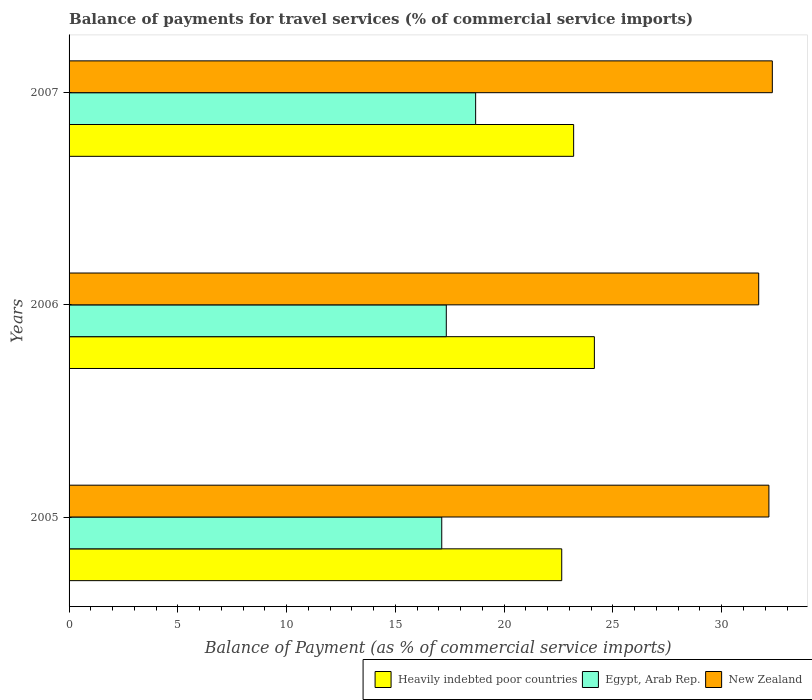How many different coloured bars are there?
Keep it short and to the point. 3. How many groups of bars are there?
Offer a very short reply. 3. Are the number of bars on each tick of the Y-axis equal?
Keep it short and to the point. Yes. How many bars are there on the 2nd tick from the top?
Make the answer very short. 3. What is the label of the 2nd group of bars from the top?
Your answer should be very brief. 2006. In how many cases, is the number of bars for a given year not equal to the number of legend labels?
Offer a very short reply. 0. What is the balance of payments for travel services in Heavily indebted poor countries in 2006?
Provide a succinct answer. 24.15. Across all years, what is the maximum balance of payments for travel services in Egypt, Arab Rep.?
Keep it short and to the point. 18.69. Across all years, what is the minimum balance of payments for travel services in New Zealand?
Ensure brevity in your answer.  31.7. In which year was the balance of payments for travel services in Heavily indebted poor countries maximum?
Keep it short and to the point. 2006. What is the total balance of payments for travel services in Heavily indebted poor countries in the graph?
Offer a very short reply. 69.99. What is the difference between the balance of payments for travel services in New Zealand in 2006 and that in 2007?
Provide a succinct answer. -0.63. What is the difference between the balance of payments for travel services in Egypt, Arab Rep. in 2006 and the balance of payments for travel services in Heavily indebted poor countries in 2007?
Ensure brevity in your answer.  -5.85. What is the average balance of payments for travel services in Heavily indebted poor countries per year?
Your answer should be compact. 23.33. In the year 2005, what is the difference between the balance of payments for travel services in Egypt, Arab Rep. and balance of payments for travel services in Heavily indebted poor countries?
Provide a succinct answer. -5.52. In how many years, is the balance of payments for travel services in Egypt, Arab Rep. greater than 22 %?
Provide a succinct answer. 0. What is the ratio of the balance of payments for travel services in Egypt, Arab Rep. in 2005 to that in 2007?
Offer a terse response. 0.92. What is the difference between the highest and the second highest balance of payments for travel services in Egypt, Arab Rep.?
Keep it short and to the point. 1.35. What is the difference between the highest and the lowest balance of payments for travel services in Egypt, Arab Rep.?
Offer a terse response. 1.56. In how many years, is the balance of payments for travel services in Egypt, Arab Rep. greater than the average balance of payments for travel services in Egypt, Arab Rep. taken over all years?
Make the answer very short. 1. Is the sum of the balance of payments for travel services in New Zealand in 2005 and 2006 greater than the maximum balance of payments for travel services in Egypt, Arab Rep. across all years?
Your answer should be compact. Yes. What does the 1st bar from the top in 2007 represents?
Make the answer very short. New Zealand. What does the 2nd bar from the bottom in 2006 represents?
Your answer should be compact. Egypt, Arab Rep. Is it the case that in every year, the sum of the balance of payments for travel services in Egypt, Arab Rep. and balance of payments for travel services in New Zealand is greater than the balance of payments for travel services in Heavily indebted poor countries?
Offer a very short reply. Yes. How many bars are there?
Ensure brevity in your answer.  9. Are the values on the major ticks of X-axis written in scientific E-notation?
Your response must be concise. No. Where does the legend appear in the graph?
Provide a succinct answer. Bottom right. How are the legend labels stacked?
Give a very brief answer. Horizontal. What is the title of the graph?
Provide a short and direct response. Balance of payments for travel services (% of commercial service imports). What is the label or title of the X-axis?
Offer a terse response. Balance of Payment (as % of commercial service imports). What is the Balance of Payment (as % of commercial service imports) of Heavily indebted poor countries in 2005?
Make the answer very short. 22.65. What is the Balance of Payment (as % of commercial service imports) in Egypt, Arab Rep. in 2005?
Your answer should be very brief. 17.13. What is the Balance of Payment (as % of commercial service imports) in New Zealand in 2005?
Make the answer very short. 32.17. What is the Balance of Payment (as % of commercial service imports) of Heavily indebted poor countries in 2006?
Your response must be concise. 24.15. What is the Balance of Payment (as % of commercial service imports) in Egypt, Arab Rep. in 2006?
Keep it short and to the point. 17.34. What is the Balance of Payment (as % of commercial service imports) in New Zealand in 2006?
Your response must be concise. 31.7. What is the Balance of Payment (as % of commercial service imports) of Heavily indebted poor countries in 2007?
Offer a terse response. 23.19. What is the Balance of Payment (as % of commercial service imports) of Egypt, Arab Rep. in 2007?
Your response must be concise. 18.69. What is the Balance of Payment (as % of commercial service imports) in New Zealand in 2007?
Your answer should be very brief. 32.33. Across all years, what is the maximum Balance of Payment (as % of commercial service imports) of Heavily indebted poor countries?
Provide a short and direct response. 24.15. Across all years, what is the maximum Balance of Payment (as % of commercial service imports) of Egypt, Arab Rep.?
Provide a short and direct response. 18.69. Across all years, what is the maximum Balance of Payment (as % of commercial service imports) of New Zealand?
Give a very brief answer. 32.33. Across all years, what is the minimum Balance of Payment (as % of commercial service imports) of Heavily indebted poor countries?
Provide a short and direct response. 22.65. Across all years, what is the minimum Balance of Payment (as % of commercial service imports) in Egypt, Arab Rep.?
Offer a very short reply. 17.13. Across all years, what is the minimum Balance of Payment (as % of commercial service imports) in New Zealand?
Keep it short and to the point. 31.7. What is the total Balance of Payment (as % of commercial service imports) in Heavily indebted poor countries in the graph?
Offer a terse response. 69.99. What is the total Balance of Payment (as % of commercial service imports) of Egypt, Arab Rep. in the graph?
Offer a terse response. 53.16. What is the total Balance of Payment (as % of commercial service imports) in New Zealand in the graph?
Offer a terse response. 96.19. What is the difference between the Balance of Payment (as % of commercial service imports) in Heavily indebted poor countries in 2005 and that in 2006?
Offer a terse response. -1.5. What is the difference between the Balance of Payment (as % of commercial service imports) of Egypt, Arab Rep. in 2005 and that in 2006?
Offer a terse response. -0.21. What is the difference between the Balance of Payment (as % of commercial service imports) in New Zealand in 2005 and that in 2006?
Offer a very short reply. 0.47. What is the difference between the Balance of Payment (as % of commercial service imports) in Heavily indebted poor countries in 2005 and that in 2007?
Provide a short and direct response. -0.55. What is the difference between the Balance of Payment (as % of commercial service imports) of Egypt, Arab Rep. in 2005 and that in 2007?
Keep it short and to the point. -1.56. What is the difference between the Balance of Payment (as % of commercial service imports) in New Zealand in 2005 and that in 2007?
Provide a succinct answer. -0.16. What is the difference between the Balance of Payment (as % of commercial service imports) of Heavily indebted poor countries in 2006 and that in 2007?
Your response must be concise. 0.95. What is the difference between the Balance of Payment (as % of commercial service imports) in Egypt, Arab Rep. in 2006 and that in 2007?
Provide a succinct answer. -1.35. What is the difference between the Balance of Payment (as % of commercial service imports) in New Zealand in 2006 and that in 2007?
Make the answer very short. -0.63. What is the difference between the Balance of Payment (as % of commercial service imports) of Heavily indebted poor countries in 2005 and the Balance of Payment (as % of commercial service imports) of Egypt, Arab Rep. in 2006?
Keep it short and to the point. 5.31. What is the difference between the Balance of Payment (as % of commercial service imports) of Heavily indebted poor countries in 2005 and the Balance of Payment (as % of commercial service imports) of New Zealand in 2006?
Your answer should be compact. -9.05. What is the difference between the Balance of Payment (as % of commercial service imports) in Egypt, Arab Rep. in 2005 and the Balance of Payment (as % of commercial service imports) in New Zealand in 2006?
Ensure brevity in your answer.  -14.57. What is the difference between the Balance of Payment (as % of commercial service imports) in Heavily indebted poor countries in 2005 and the Balance of Payment (as % of commercial service imports) in Egypt, Arab Rep. in 2007?
Give a very brief answer. 3.96. What is the difference between the Balance of Payment (as % of commercial service imports) in Heavily indebted poor countries in 2005 and the Balance of Payment (as % of commercial service imports) in New Zealand in 2007?
Offer a terse response. -9.68. What is the difference between the Balance of Payment (as % of commercial service imports) of Egypt, Arab Rep. in 2005 and the Balance of Payment (as % of commercial service imports) of New Zealand in 2007?
Provide a short and direct response. -15.2. What is the difference between the Balance of Payment (as % of commercial service imports) in Heavily indebted poor countries in 2006 and the Balance of Payment (as % of commercial service imports) in Egypt, Arab Rep. in 2007?
Give a very brief answer. 5.46. What is the difference between the Balance of Payment (as % of commercial service imports) of Heavily indebted poor countries in 2006 and the Balance of Payment (as % of commercial service imports) of New Zealand in 2007?
Offer a terse response. -8.18. What is the difference between the Balance of Payment (as % of commercial service imports) in Egypt, Arab Rep. in 2006 and the Balance of Payment (as % of commercial service imports) in New Zealand in 2007?
Offer a very short reply. -14.99. What is the average Balance of Payment (as % of commercial service imports) in Heavily indebted poor countries per year?
Your answer should be very brief. 23.33. What is the average Balance of Payment (as % of commercial service imports) in Egypt, Arab Rep. per year?
Give a very brief answer. 17.72. What is the average Balance of Payment (as % of commercial service imports) in New Zealand per year?
Provide a short and direct response. 32.06. In the year 2005, what is the difference between the Balance of Payment (as % of commercial service imports) in Heavily indebted poor countries and Balance of Payment (as % of commercial service imports) in Egypt, Arab Rep.?
Your answer should be compact. 5.52. In the year 2005, what is the difference between the Balance of Payment (as % of commercial service imports) of Heavily indebted poor countries and Balance of Payment (as % of commercial service imports) of New Zealand?
Keep it short and to the point. -9.52. In the year 2005, what is the difference between the Balance of Payment (as % of commercial service imports) in Egypt, Arab Rep. and Balance of Payment (as % of commercial service imports) in New Zealand?
Your answer should be very brief. -15.04. In the year 2006, what is the difference between the Balance of Payment (as % of commercial service imports) in Heavily indebted poor countries and Balance of Payment (as % of commercial service imports) in Egypt, Arab Rep.?
Offer a very short reply. 6.81. In the year 2006, what is the difference between the Balance of Payment (as % of commercial service imports) of Heavily indebted poor countries and Balance of Payment (as % of commercial service imports) of New Zealand?
Your answer should be very brief. -7.55. In the year 2006, what is the difference between the Balance of Payment (as % of commercial service imports) of Egypt, Arab Rep. and Balance of Payment (as % of commercial service imports) of New Zealand?
Make the answer very short. -14.36. In the year 2007, what is the difference between the Balance of Payment (as % of commercial service imports) in Heavily indebted poor countries and Balance of Payment (as % of commercial service imports) in Egypt, Arab Rep.?
Offer a terse response. 4.5. In the year 2007, what is the difference between the Balance of Payment (as % of commercial service imports) in Heavily indebted poor countries and Balance of Payment (as % of commercial service imports) in New Zealand?
Provide a short and direct response. -9.13. In the year 2007, what is the difference between the Balance of Payment (as % of commercial service imports) in Egypt, Arab Rep. and Balance of Payment (as % of commercial service imports) in New Zealand?
Your answer should be compact. -13.64. What is the ratio of the Balance of Payment (as % of commercial service imports) of Heavily indebted poor countries in 2005 to that in 2006?
Your response must be concise. 0.94. What is the ratio of the Balance of Payment (as % of commercial service imports) of Egypt, Arab Rep. in 2005 to that in 2006?
Offer a terse response. 0.99. What is the ratio of the Balance of Payment (as % of commercial service imports) of New Zealand in 2005 to that in 2006?
Give a very brief answer. 1.01. What is the ratio of the Balance of Payment (as % of commercial service imports) in Heavily indebted poor countries in 2005 to that in 2007?
Give a very brief answer. 0.98. What is the ratio of the Balance of Payment (as % of commercial service imports) of New Zealand in 2005 to that in 2007?
Your response must be concise. 1. What is the ratio of the Balance of Payment (as % of commercial service imports) in Heavily indebted poor countries in 2006 to that in 2007?
Provide a succinct answer. 1.04. What is the ratio of the Balance of Payment (as % of commercial service imports) in Egypt, Arab Rep. in 2006 to that in 2007?
Provide a short and direct response. 0.93. What is the ratio of the Balance of Payment (as % of commercial service imports) of New Zealand in 2006 to that in 2007?
Offer a very short reply. 0.98. What is the difference between the highest and the second highest Balance of Payment (as % of commercial service imports) of Heavily indebted poor countries?
Your answer should be compact. 0.95. What is the difference between the highest and the second highest Balance of Payment (as % of commercial service imports) of Egypt, Arab Rep.?
Your answer should be compact. 1.35. What is the difference between the highest and the second highest Balance of Payment (as % of commercial service imports) in New Zealand?
Offer a very short reply. 0.16. What is the difference between the highest and the lowest Balance of Payment (as % of commercial service imports) in Heavily indebted poor countries?
Provide a short and direct response. 1.5. What is the difference between the highest and the lowest Balance of Payment (as % of commercial service imports) in Egypt, Arab Rep.?
Your answer should be very brief. 1.56. What is the difference between the highest and the lowest Balance of Payment (as % of commercial service imports) in New Zealand?
Provide a succinct answer. 0.63. 